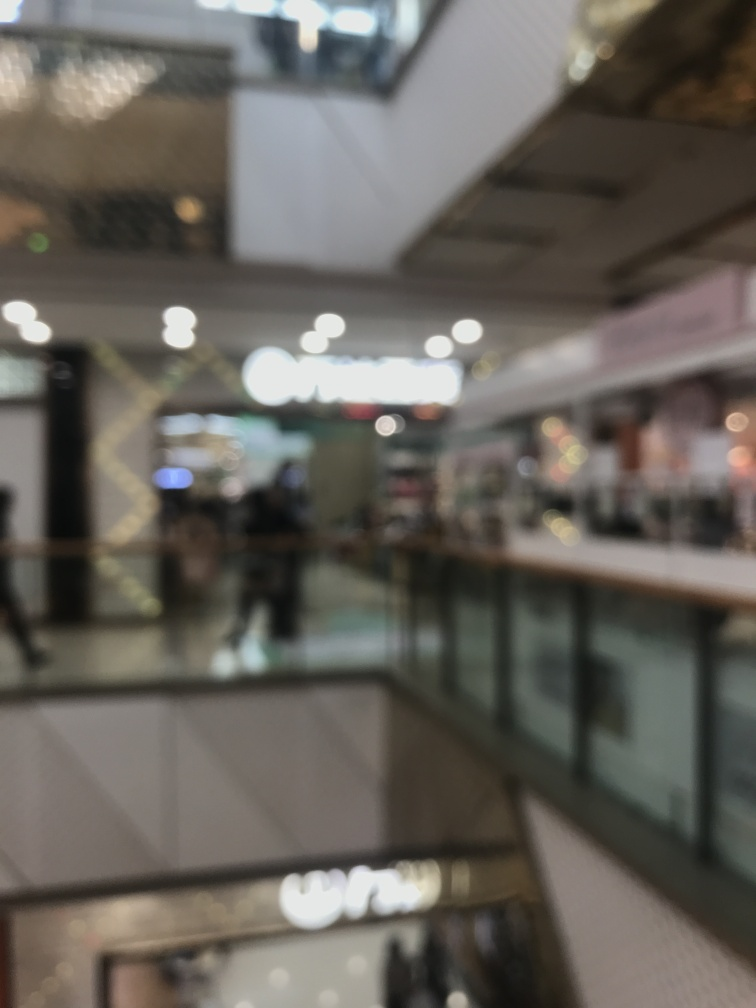What is the overall clarity of the image?
A. High
B. Clear
C. Very low
Answer with the option's letter from the given choices directly. The overall clarity of the image is very low, as most details are obscured and there is a significant lack of sharpness. This can be due to factors like an unfocused camera, motion blur, or other photographic anomalies that result in a less-than-clear picture. 